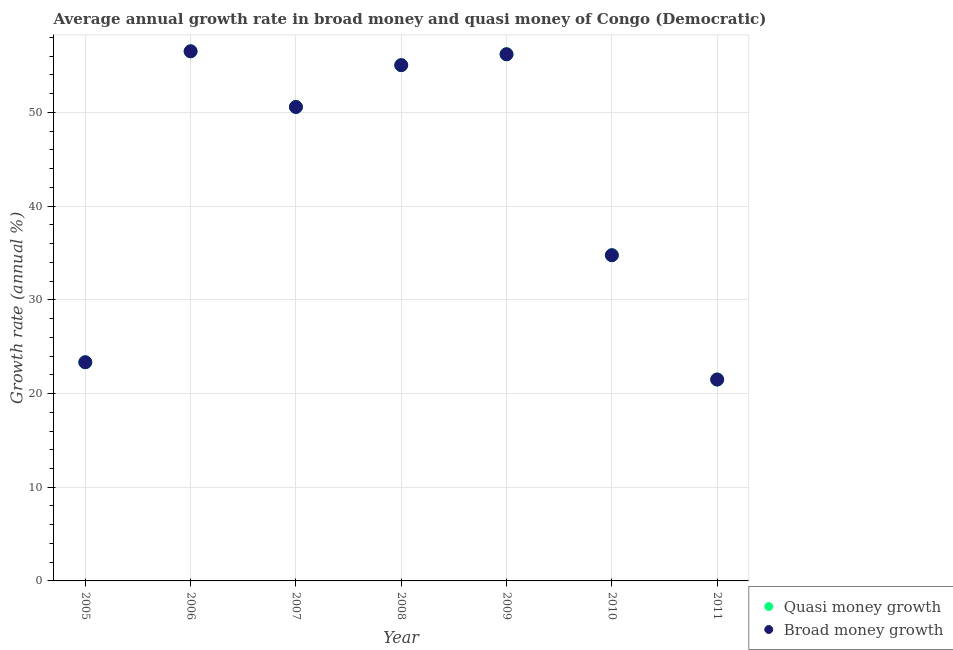What is the annual growth rate in quasi money in 2009?
Your answer should be very brief. 56.21. Across all years, what is the maximum annual growth rate in broad money?
Ensure brevity in your answer.  56.53. Across all years, what is the minimum annual growth rate in quasi money?
Provide a succinct answer. 21.5. In which year was the annual growth rate in broad money maximum?
Your answer should be compact. 2006. What is the total annual growth rate in quasi money in the graph?
Your response must be concise. 297.98. What is the difference between the annual growth rate in broad money in 2007 and that in 2008?
Offer a terse response. -4.46. What is the difference between the annual growth rate in quasi money in 2005 and the annual growth rate in broad money in 2008?
Ensure brevity in your answer.  -31.71. What is the average annual growth rate in broad money per year?
Give a very brief answer. 42.57. In the year 2006, what is the difference between the annual growth rate in broad money and annual growth rate in quasi money?
Your answer should be very brief. 0. What is the ratio of the annual growth rate in quasi money in 2008 to that in 2009?
Make the answer very short. 0.98. Is the annual growth rate in quasi money in 2008 less than that in 2010?
Your answer should be compact. No. What is the difference between the highest and the second highest annual growth rate in quasi money?
Your response must be concise. 0.32. What is the difference between the highest and the lowest annual growth rate in quasi money?
Give a very brief answer. 35.03. Is the annual growth rate in broad money strictly greater than the annual growth rate in quasi money over the years?
Offer a terse response. No. Is the annual growth rate in quasi money strictly less than the annual growth rate in broad money over the years?
Your answer should be very brief. No. What is the difference between two consecutive major ticks on the Y-axis?
Your answer should be compact. 10. Does the graph contain grids?
Your answer should be very brief. Yes. What is the title of the graph?
Make the answer very short. Average annual growth rate in broad money and quasi money of Congo (Democratic). What is the label or title of the Y-axis?
Your answer should be compact. Growth rate (annual %). What is the Growth rate (annual %) in Quasi money growth in 2005?
Keep it short and to the point. 23.34. What is the Growth rate (annual %) in Broad money growth in 2005?
Keep it short and to the point. 23.34. What is the Growth rate (annual %) of Quasi money growth in 2006?
Provide a succinct answer. 56.53. What is the Growth rate (annual %) of Broad money growth in 2006?
Provide a short and direct response. 56.53. What is the Growth rate (annual %) in Quasi money growth in 2007?
Give a very brief answer. 50.59. What is the Growth rate (annual %) of Broad money growth in 2007?
Provide a succinct answer. 50.59. What is the Growth rate (annual %) of Quasi money growth in 2008?
Your answer should be very brief. 55.05. What is the Growth rate (annual %) of Broad money growth in 2008?
Keep it short and to the point. 55.05. What is the Growth rate (annual %) in Quasi money growth in 2009?
Give a very brief answer. 56.21. What is the Growth rate (annual %) of Broad money growth in 2009?
Offer a terse response. 56.21. What is the Growth rate (annual %) in Quasi money growth in 2010?
Your answer should be compact. 34.76. What is the Growth rate (annual %) of Broad money growth in 2010?
Keep it short and to the point. 34.76. What is the Growth rate (annual %) in Quasi money growth in 2011?
Make the answer very short. 21.5. What is the Growth rate (annual %) in Broad money growth in 2011?
Ensure brevity in your answer.  21.5. Across all years, what is the maximum Growth rate (annual %) of Quasi money growth?
Give a very brief answer. 56.53. Across all years, what is the maximum Growth rate (annual %) in Broad money growth?
Your response must be concise. 56.53. Across all years, what is the minimum Growth rate (annual %) of Quasi money growth?
Provide a succinct answer. 21.5. Across all years, what is the minimum Growth rate (annual %) of Broad money growth?
Provide a succinct answer. 21.5. What is the total Growth rate (annual %) of Quasi money growth in the graph?
Your answer should be compact. 297.98. What is the total Growth rate (annual %) in Broad money growth in the graph?
Your answer should be very brief. 297.98. What is the difference between the Growth rate (annual %) in Quasi money growth in 2005 and that in 2006?
Your response must be concise. -33.19. What is the difference between the Growth rate (annual %) of Broad money growth in 2005 and that in 2006?
Offer a very short reply. -33.19. What is the difference between the Growth rate (annual %) of Quasi money growth in 2005 and that in 2007?
Give a very brief answer. -27.25. What is the difference between the Growth rate (annual %) in Broad money growth in 2005 and that in 2007?
Provide a short and direct response. -27.25. What is the difference between the Growth rate (annual %) in Quasi money growth in 2005 and that in 2008?
Give a very brief answer. -31.71. What is the difference between the Growth rate (annual %) of Broad money growth in 2005 and that in 2008?
Give a very brief answer. -31.71. What is the difference between the Growth rate (annual %) in Quasi money growth in 2005 and that in 2009?
Keep it short and to the point. -32.87. What is the difference between the Growth rate (annual %) of Broad money growth in 2005 and that in 2009?
Offer a very short reply. -32.87. What is the difference between the Growth rate (annual %) in Quasi money growth in 2005 and that in 2010?
Make the answer very short. -11.42. What is the difference between the Growth rate (annual %) of Broad money growth in 2005 and that in 2010?
Your answer should be compact. -11.42. What is the difference between the Growth rate (annual %) of Quasi money growth in 2005 and that in 2011?
Make the answer very short. 1.84. What is the difference between the Growth rate (annual %) in Broad money growth in 2005 and that in 2011?
Offer a terse response. 1.84. What is the difference between the Growth rate (annual %) of Quasi money growth in 2006 and that in 2007?
Your answer should be compact. 5.94. What is the difference between the Growth rate (annual %) in Broad money growth in 2006 and that in 2007?
Make the answer very short. 5.94. What is the difference between the Growth rate (annual %) in Quasi money growth in 2006 and that in 2008?
Your answer should be very brief. 1.48. What is the difference between the Growth rate (annual %) of Broad money growth in 2006 and that in 2008?
Your answer should be compact. 1.48. What is the difference between the Growth rate (annual %) in Quasi money growth in 2006 and that in 2009?
Provide a succinct answer. 0.32. What is the difference between the Growth rate (annual %) in Broad money growth in 2006 and that in 2009?
Offer a terse response. 0.32. What is the difference between the Growth rate (annual %) in Quasi money growth in 2006 and that in 2010?
Your answer should be compact. 21.77. What is the difference between the Growth rate (annual %) in Broad money growth in 2006 and that in 2010?
Offer a terse response. 21.77. What is the difference between the Growth rate (annual %) in Quasi money growth in 2006 and that in 2011?
Offer a terse response. 35.03. What is the difference between the Growth rate (annual %) of Broad money growth in 2006 and that in 2011?
Offer a terse response. 35.03. What is the difference between the Growth rate (annual %) of Quasi money growth in 2007 and that in 2008?
Give a very brief answer. -4.46. What is the difference between the Growth rate (annual %) of Broad money growth in 2007 and that in 2008?
Your answer should be very brief. -4.46. What is the difference between the Growth rate (annual %) in Quasi money growth in 2007 and that in 2009?
Your response must be concise. -5.63. What is the difference between the Growth rate (annual %) of Broad money growth in 2007 and that in 2009?
Ensure brevity in your answer.  -5.63. What is the difference between the Growth rate (annual %) in Quasi money growth in 2007 and that in 2010?
Your answer should be very brief. 15.82. What is the difference between the Growth rate (annual %) of Broad money growth in 2007 and that in 2010?
Provide a succinct answer. 15.82. What is the difference between the Growth rate (annual %) in Quasi money growth in 2007 and that in 2011?
Offer a very short reply. 29.09. What is the difference between the Growth rate (annual %) in Broad money growth in 2007 and that in 2011?
Make the answer very short. 29.09. What is the difference between the Growth rate (annual %) of Quasi money growth in 2008 and that in 2009?
Your response must be concise. -1.16. What is the difference between the Growth rate (annual %) in Broad money growth in 2008 and that in 2009?
Your answer should be compact. -1.16. What is the difference between the Growth rate (annual %) of Quasi money growth in 2008 and that in 2010?
Provide a succinct answer. 20.29. What is the difference between the Growth rate (annual %) in Broad money growth in 2008 and that in 2010?
Ensure brevity in your answer.  20.29. What is the difference between the Growth rate (annual %) of Quasi money growth in 2008 and that in 2011?
Offer a very short reply. 33.55. What is the difference between the Growth rate (annual %) of Broad money growth in 2008 and that in 2011?
Your answer should be compact. 33.55. What is the difference between the Growth rate (annual %) of Quasi money growth in 2009 and that in 2010?
Your answer should be compact. 21.45. What is the difference between the Growth rate (annual %) in Broad money growth in 2009 and that in 2010?
Offer a very short reply. 21.45. What is the difference between the Growth rate (annual %) of Quasi money growth in 2009 and that in 2011?
Offer a very short reply. 34.72. What is the difference between the Growth rate (annual %) of Broad money growth in 2009 and that in 2011?
Give a very brief answer. 34.72. What is the difference between the Growth rate (annual %) of Quasi money growth in 2010 and that in 2011?
Your answer should be very brief. 13.27. What is the difference between the Growth rate (annual %) in Broad money growth in 2010 and that in 2011?
Provide a succinct answer. 13.27. What is the difference between the Growth rate (annual %) of Quasi money growth in 2005 and the Growth rate (annual %) of Broad money growth in 2006?
Ensure brevity in your answer.  -33.19. What is the difference between the Growth rate (annual %) of Quasi money growth in 2005 and the Growth rate (annual %) of Broad money growth in 2007?
Make the answer very short. -27.25. What is the difference between the Growth rate (annual %) in Quasi money growth in 2005 and the Growth rate (annual %) in Broad money growth in 2008?
Your answer should be compact. -31.71. What is the difference between the Growth rate (annual %) in Quasi money growth in 2005 and the Growth rate (annual %) in Broad money growth in 2009?
Offer a very short reply. -32.87. What is the difference between the Growth rate (annual %) of Quasi money growth in 2005 and the Growth rate (annual %) of Broad money growth in 2010?
Offer a terse response. -11.42. What is the difference between the Growth rate (annual %) of Quasi money growth in 2005 and the Growth rate (annual %) of Broad money growth in 2011?
Offer a terse response. 1.84. What is the difference between the Growth rate (annual %) of Quasi money growth in 2006 and the Growth rate (annual %) of Broad money growth in 2007?
Make the answer very short. 5.94. What is the difference between the Growth rate (annual %) in Quasi money growth in 2006 and the Growth rate (annual %) in Broad money growth in 2008?
Your response must be concise. 1.48. What is the difference between the Growth rate (annual %) in Quasi money growth in 2006 and the Growth rate (annual %) in Broad money growth in 2009?
Offer a very short reply. 0.32. What is the difference between the Growth rate (annual %) in Quasi money growth in 2006 and the Growth rate (annual %) in Broad money growth in 2010?
Make the answer very short. 21.77. What is the difference between the Growth rate (annual %) of Quasi money growth in 2006 and the Growth rate (annual %) of Broad money growth in 2011?
Ensure brevity in your answer.  35.03. What is the difference between the Growth rate (annual %) in Quasi money growth in 2007 and the Growth rate (annual %) in Broad money growth in 2008?
Offer a terse response. -4.46. What is the difference between the Growth rate (annual %) of Quasi money growth in 2007 and the Growth rate (annual %) of Broad money growth in 2009?
Offer a terse response. -5.63. What is the difference between the Growth rate (annual %) of Quasi money growth in 2007 and the Growth rate (annual %) of Broad money growth in 2010?
Keep it short and to the point. 15.82. What is the difference between the Growth rate (annual %) in Quasi money growth in 2007 and the Growth rate (annual %) in Broad money growth in 2011?
Offer a very short reply. 29.09. What is the difference between the Growth rate (annual %) of Quasi money growth in 2008 and the Growth rate (annual %) of Broad money growth in 2009?
Give a very brief answer. -1.16. What is the difference between the Growth rate (annual %) in Quasi money growth in 2008 and the Growth rate (annual %) in Broad money growth in 2010?
Give a very brief answer. 20.29. What is the difference between the Growth rate (annual %) in Quasi money growth in 2008 and the Growth rate (annual %) in Broad money growth in 2011?
Your answer should be very brief. 33.55. What is the difference between the Growth rate (annual %) of Quasi money growth in 2009 and the Growth rate (annual %) of Broad money growth in 2010?
Provide a short and direct response. 21.45. What is the difference between the Growth rate (annual %) of Quasi money growth in 2009 and the Growth rate (annual %) of Broad money growth in 2011?
Offer a very short reply. 34.72. What is the difference between the Growth rate (annual %) of Quasi money growth in 2010 and the Growth rate (annual %) of Broad money growth in 2011?
Offer a very short reply. 13.27. What is the average Growth rate (annual %) in Quasi money growth per year?
Keep it short and to the point. 42.57. What is the average Growth rate (annual %) of Broad money growth per year?
Give a very brief answer. 42.57. In the year 2005, what is the difference between the Growth rate (annual %) of Quasi money growth and Growth rate (annual %) of Broad money growth?
Keep it short and to the point. 0. In the year 2008, what is the difference between the Growth rate (annual %) of Quasi money growth and Growth rate (annual %) of Broad money growth?
Provide a short and direct response. 0. In the year 2009, what is the difference between the Growth rate (annual %) of Quasi money growth and Growth rate (annual %) of Broad money growth?
Your answer should be very brief. 0. In the year 2011, what is the difference between the Growth rate (annual %) of Quasi money growth and Growth rate (annual %) of Broad money growth?
Offer a very short reply. 0. What is the ratio of the Growth rate (annual %) of Quasi money growth in 2005 to that in 2006?
Your answer should be compact. 0.41. What is the ratio of the Growth rate (annual %) of Broad money growth in 2005 to that in 2006?
Offer a very short reply. 0.41. What is the ratio of the Growth rate (annual %) in Quasi money growth in 2005 to that in 2007?
Keep it short and to the point. 0.46. What is the ratio of the Growth rate (annual %) in Broad money growth in 2005 to that in 2007?
Your answer should be compact. 0.46. What is the ratio of the Growth rate (annual %) in Quasi money growth in 2005 to that in 2008?
Ensure brevity in your answer.  0.42. What is the ratio of the Growth rate (annual %) of Broad money growth in 2005 to that in 2008?
Your response must be concise. 0.42. What is the ratio of the Growth rate (annual %) of Quasi money growth in 2005 to that in 2009?
Your answer should be very brief. 0.42. What is the ratio of the Growth rate (annual %) in Broad money growth in 2005 to that in 2009?
Provide a succinct answer. 0.42. What is the ratio of the Growth rate (annual %) of Quasi money growth in 2005 to that in 2010?
Offer a terse response. 0.67. What is the ratio of the Growth rate (annual %) in Broad money growth in 2005 to that in 2010?
Your answer should be compact. 0.67. What is the ratio of the Growth rate (annual %) of Quasi money growth in 2005 to that in 2011?
Ensure brevity in your answer.  1.09. What is the ratio of the Growth rate (annual %) of Broad money growth in 2005 to that in 2011?
Your answer should be compact. 1.09. What is the ratio of the Growth rate (annual %) of Quasi money growth in 2006 to that in 2007?
Keep it short and to the point. 1.12. What is the ratio of the Growth rate (annual %) of Broad money growth in 2006 to that in 2007?
Provide a succinct answer. 1.12. What is the ratio of the Growth rate (annual %) in Quasi money growth in 2006 to that in 2008?
Make the answer very short. 1.03. What is the ratio of the Growth rate (annual %) in Broad money growth in 2006 to that in 2008?
Make the answer very short. 1.03. What is the ratio of the Growth rate (annual %) in Quasi money growth in 2006 to that in 2009?
Your answer should be compact. 1.01. What is the ratio of the Growth rate (annual %) of Broad money growth in 2006 to that in 2009?
Keep it short and to the point. 1.01. What is the ratio of the Growth rate (annual %) of Quasi money growth in 2006 to that in 2010?
Give a very brief answer. 1.63. What is the ratio of the Growth rate (annual %) of Broad money growth in 2006 to that in 2010?
Provide a short and direct response. 1.63. What is the ratio of the Growth rate (annual %) of Quasi money growth in 2006 to that in 2011?
Your response must be concise. 2.63. What is the ratio of the Growth rate (annual %) in Broad money growth in 2006 to that in 2011?
Offer a very short reply. 2.63. What is the ratio of the Growth rate (annual %) in Quasi money growth in 2007 to that in 2008?
Your response must be concise. 0.92. What is the ratio of the Growth rate (annual %) in Broad money growth in 2007 to that in 2008?
Make the answer very short. 0.92. What is the ratio of the Growth rate (annual %) in Quasi money growth in 2007 to that in 2009?
Keep it short and to the point. 0.9. What is the ratio of the Growth rate (annual %) in Broad money growth in 2007 to that in 2009?
Keep it short and to the point. 0.9. What is the ratio of the Growth rate (annual %) of Quasi money growth in 2007 to that in 2010?
Make the answer very short. 1.46. What is the ratio of the Growth rate (annual %) in Broad money growth in 2007 to that in 2010?
Give a very brief answer. 1.46. What is the ratio of the Growth rate (annual %) of Quasi money growth in 2007 to that in 2011?
Provide a short and direct response. 2.35. What is the ratio of the Growth rate (annual %) of Broad money growth in 2007 to that in 2011?
Offer a very short reply. 2.35. What is the ratio of the Growth rate (annual %) of Quasi money growth in 2008 to that in 2009?
Offer a terse response. 0.98. What is the ratio of the Growth rate (annual %) of Broad money growth in 2008 to that in 2009?
Offer a very short reply. 0.98. What is the ratio of the Growth rate (annual %) in Quasi money growth in 2008 to that in 2010?
Provide a short and direct response. 1.58. What is the ratio of the Growth rate (annual %) in Broad money growth in 2008 to that in 2010?
Keep it short and to the point. 1.58. What is the ratio of the Growth rate (annual %) in Quasi money growth in 2008 to that in 2011?
Your answer should be very brief. 2.56. What is the ratio of the Growth rate (annual %) in Broad money growth in 2008 to that in 2011?
Make the answer very short. 2.56. What is the ratio of the Growth rate (annual %) of Quasi money growth in 2009 to that in 2010?
Offer a terse response. 1.62. What is the ratio of the Growth rate (annual %) of Broad money growth in 2009 to that in 2010?
Make the answer very short. 1.62. What is the ratio of the Growth rate (annual %) of Quasi money growth in 2009 to that in 2011?
Provide a short and direct response. 2.62. What is the ratio of the Growth rate (annual %) in Broad money growth in 2009 to that in 2011?
Your answer should be very brief. 2.62. What is the ratio of the Growth rate (annual %) of Quasi money growth in 2010 to that in 2011?
Keep it short and to the point. 1.62. What is the ratio of the Growth rate (annual %) in Broad money growth in 2010 to that in 2011?
Give a very brief answer. 1.62. What is the difference between the highest and the second highest Growth rate (annual %) in Quasi money growth?
Make the answer very short. 0.32. What is the difference between the highest and the second highest Growth rate (annual %) of Broad money growth?
Provide a short and direct response. 0.32. What is the difference between the highest and the lowest Growth rate (annual %) in Quasi money growth?
Your response must be concise. 35.03. What is the difference between the highest and the lowest Growth rate (annual %) of Broad money growth?
Give a very brief answer. 35.03. 